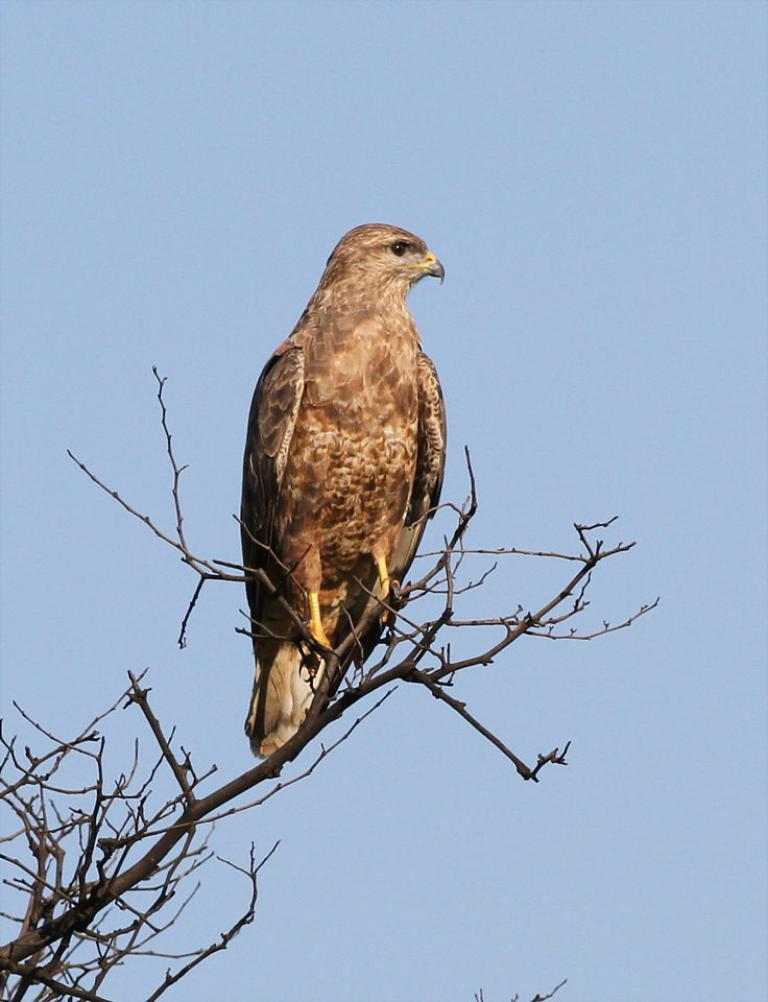What type of animal can be seen in the image? There is a bird in the image. Where is the bird located in the image? The bird is on the branch of a dried tree. What is the color of the bird? The bird is brown in color. What can be seen in the background of the image? There is a sky visible in the background of the image. What type of garden can be seen in the image? There is no garden present in the image; it features a bird on the branch of a dried tree with a visible sky in the background. 